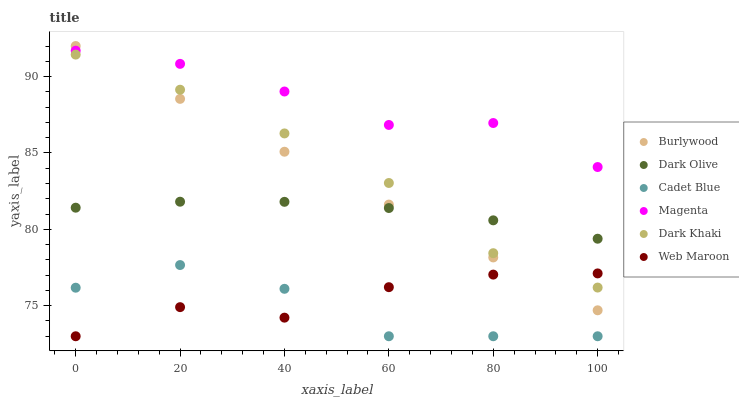Does Cadet Blue have the minimum area under the curve?
Answer yes or no. Yes. Does Magenta have the maximum area under the curve?
Answer yes or no. Yes. Does Burlywood have the minimum area under the curve?
Answer yes or no. No. Does Burlywood have the maximum area under the curve?
Answer yes or no. No. Is Burlywood the smoothest?
Answer yes or no. Yes. Is Cadet Blue the roughest?
Answer yes or no. Yes. Is Dark Olive the smoothest?
Answer yes or no. No. Is Dark Olive the roughest?
Answer yes or no. No. Does Cadet Blue have the lowest value?
Answer yes or no. Yes. Does Burlywood have the lowest value?
Answer yes or no. No. Does Burlywood have the highest value?
Answer yes or no. Yes. Does Dark Olive have the highest value?
Answer yes or no. No. Is Cadet Blue less than Magenta?
Answer yes or no. Yes. Is Burlywood greater than Cadet Blue?
Answer yes or no. Yes. Does Dark Olive intersect Burlywood?
Answer yes or no. Yes. Is Dark Olive less than Burlywood?
Answer yes or no. No. Is Dark Olive greater than Burlywood?
Answer yes or no. No. Does Cadet Blue intersect Magenta?
Answer yes or no. No. 